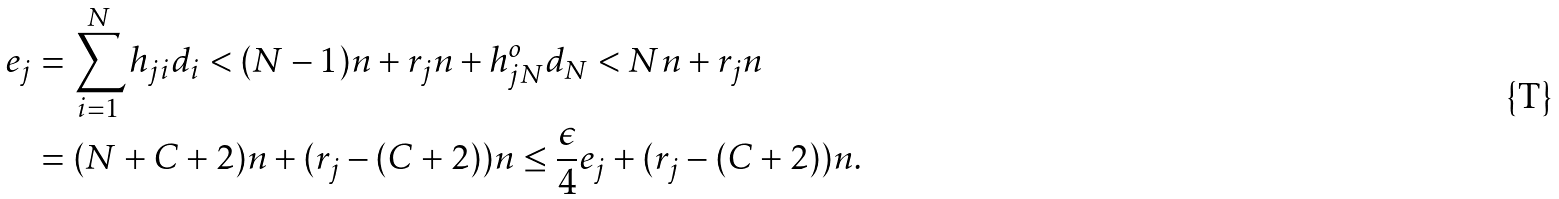<formula> <loc_0><loc_0><loc_500><loc_500>e _ { j } & = \sum _ { i = 1 } ^ { N } h _ { j i } d _ { i } < ( N - 1 ) n + r _ { j } n + h _ { j N } ^ { o } d _ { N } < N n + r _ { j } n \\ & = ( N + C + 2 ) n + ( r _ { j } - ( C + 2 ) ) n \leq \frac { \epsilon } 4 e _ { j } + ( r _ { j } - ( C + 2 ) ) n .</formula> 